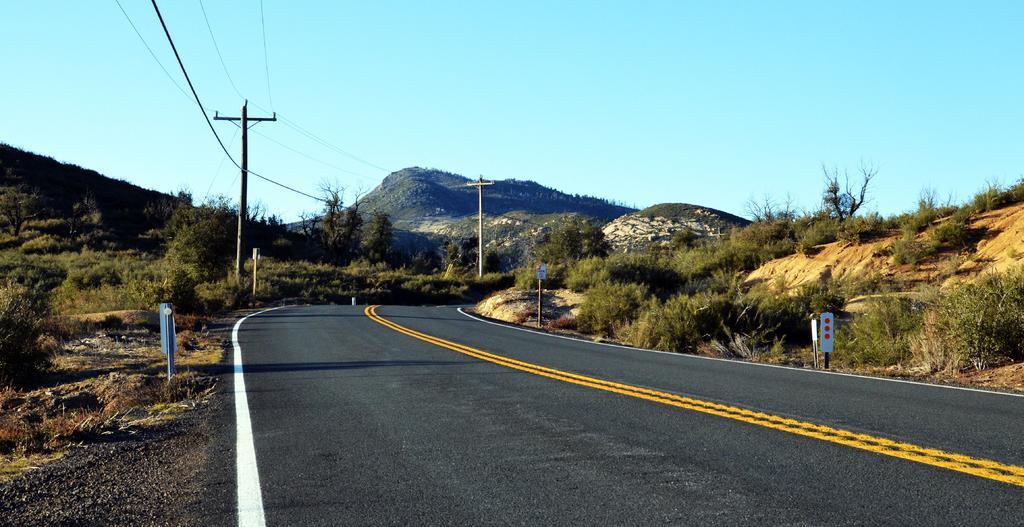Can you describe this image briefly? In this picture we can observe one way road. There are some poles and wires in this picture. We can observe some plants here. In the background there is a hill and a sky. 